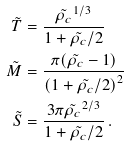<formula> <loc_0><loc_0><loc_500><loc_500>\tilde { T } & = \frac { \tilde { \rho _ { c } } ^ { 1 / 3 } } { 1 + \tilde { \rho _ { c } } / 2 } \\ \tilde { M } & = \frac { \pi ( \tilde { \rho _ { c } } - 1 ) } { \left ( 1 + \tilde { \rho _ { c } } / 2 \right ) ^ { 2 } } \\ \tilde { S } & = \frac { 3 \pi \tilde { \rho _ { c } } ^ { 2 / 3 } } { 1 + \tilde { \rho _ { c } } / 2 } \, .</formula> 